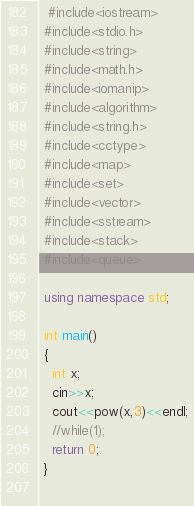Convert code to text. <code><loc_0><loc_0><loc_500><loc_500><_C++_>  #include<iostream>
 #include<stdio.h>
 #include<string>
 #include<math.h>
 #include<iomanip>
 #include<algorithm>
 #include<string.h>
 #include<cctype>
 #include<map>
 #include<set>
 #include<vector>
 #include<sstream>
 #include<stack>
 #include<queue>
 
 using namespace std;
 
 int main()
 {
   int x;
   cin>>x;
   cout<<pow(x,3)<<endl;
   //while(1);
   return 0;
 }
 </code> 